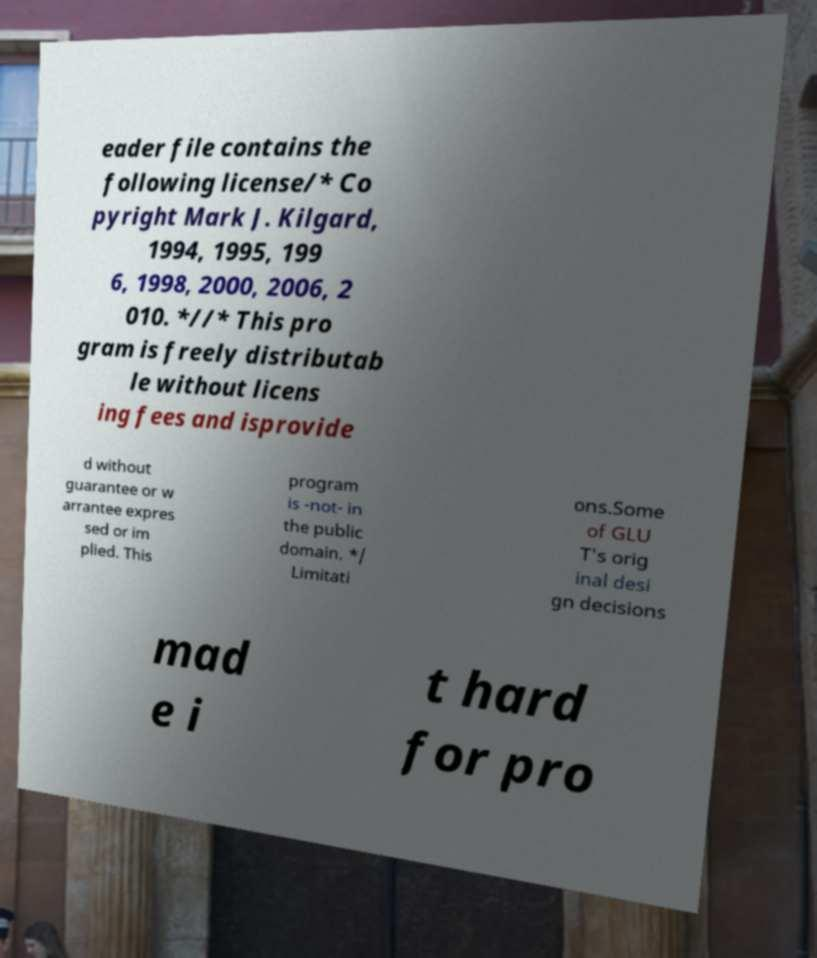Could you extract and type out the text from this image? eader file contains the following license/* Co pyright Mark J. Kilgard, 1994, 1995, 199 6, 1998, 2000, 2006, 2 010. *//* This pro gram is freely distributab le without licens ing fees and isprovide d without guarantee or w arrantee expres sed or im plied. This program is -not- in the public domain. */ Limitati ons.Some of GLU T's orig inal desi gn decisions mad e i t hard for pro 